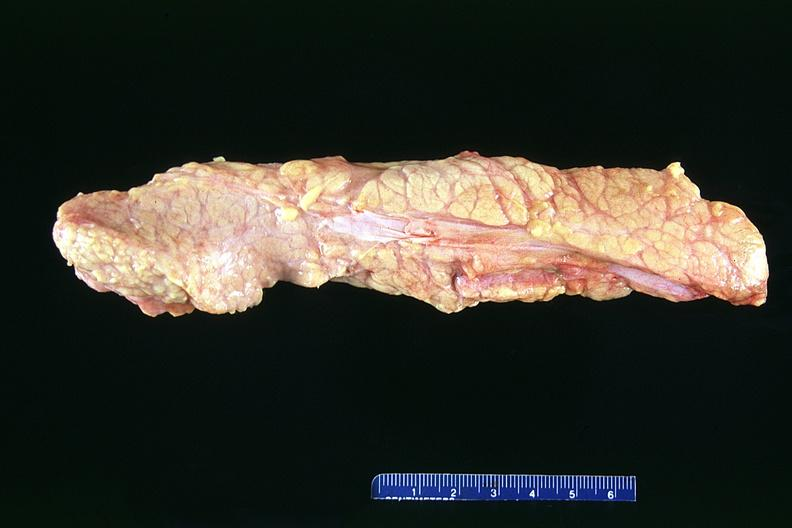does total effacement case show normal pancreas?
Answer the question using a single word or phrase. No 